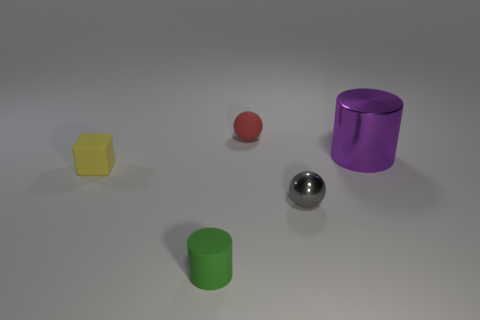Add 1 big metal objects. How many objects exist? 6 Subtract all cubes. How many objects are left? 4 Subtract 1 cubes. How many cubes are left? 0 Add 4 green cylinders. How many green cylinders exist? 5 Subtract all green cylinders. How many cylinders are left? 1 Subtract 0 brown balls. How many objects are left? 5 Subtract all cyan spheres. Subtract all cyan cubes. How many spheres are left? 2 Subtract all brown balls. How many purple cylinders are left? 1 Subtract all tiny yellow metallic spheres. Subtract all tiny yellow blocks. How many objects are left? 4 Add 3 small metallic things. How many small metallic things are left? 4 